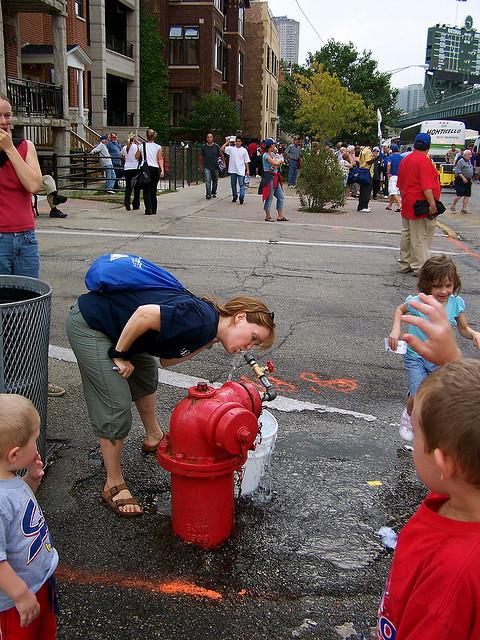What is red object used for?
Write a very short answer. Water. What is this person drinking?
Concise answer only. Water. Is this picture taken in winter?
Keep it brief. No. 